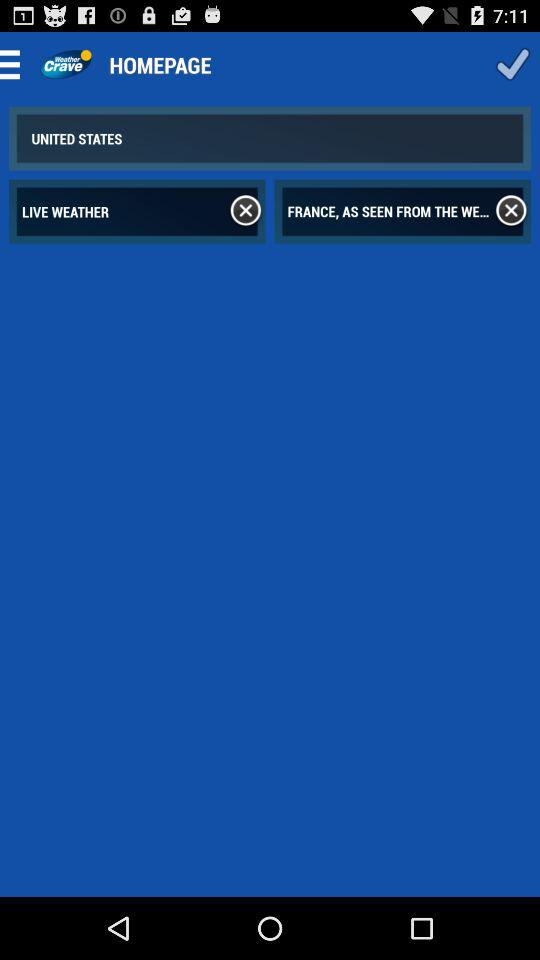What is the application name? The application name is "Weather Crave". 